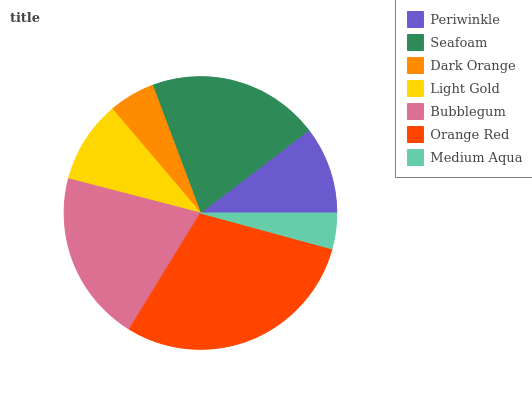Is Medium Aqua the minimum?
Answer yes or no. Yes. Is Orange Red the maximum?
Answer yes or no. Yes. Is Seafoam the minimum?
Answer yes or no. No. Is Seafoam the maximum?
Answer yes or no. No. Is Seafoam greater than Periwinkle?
Answer yes or no. Yes. Is Periwinkle less than Seafoam?
Answer yes or no. Yes. Is Periwinkle greater than Seafoam?
Answer yes or no. No. Is Seafoam less than Periwinkle?
Answer yes or no. No. Is Periwinkle the high median?
Answer yes or no. Yes. Is Periwinkle the low median?
Answer yes or no. Yes. Is Bubblegum the high median?
Answer yes or no. No. Is Orange Red the low median?
Answer yes or no. No. 